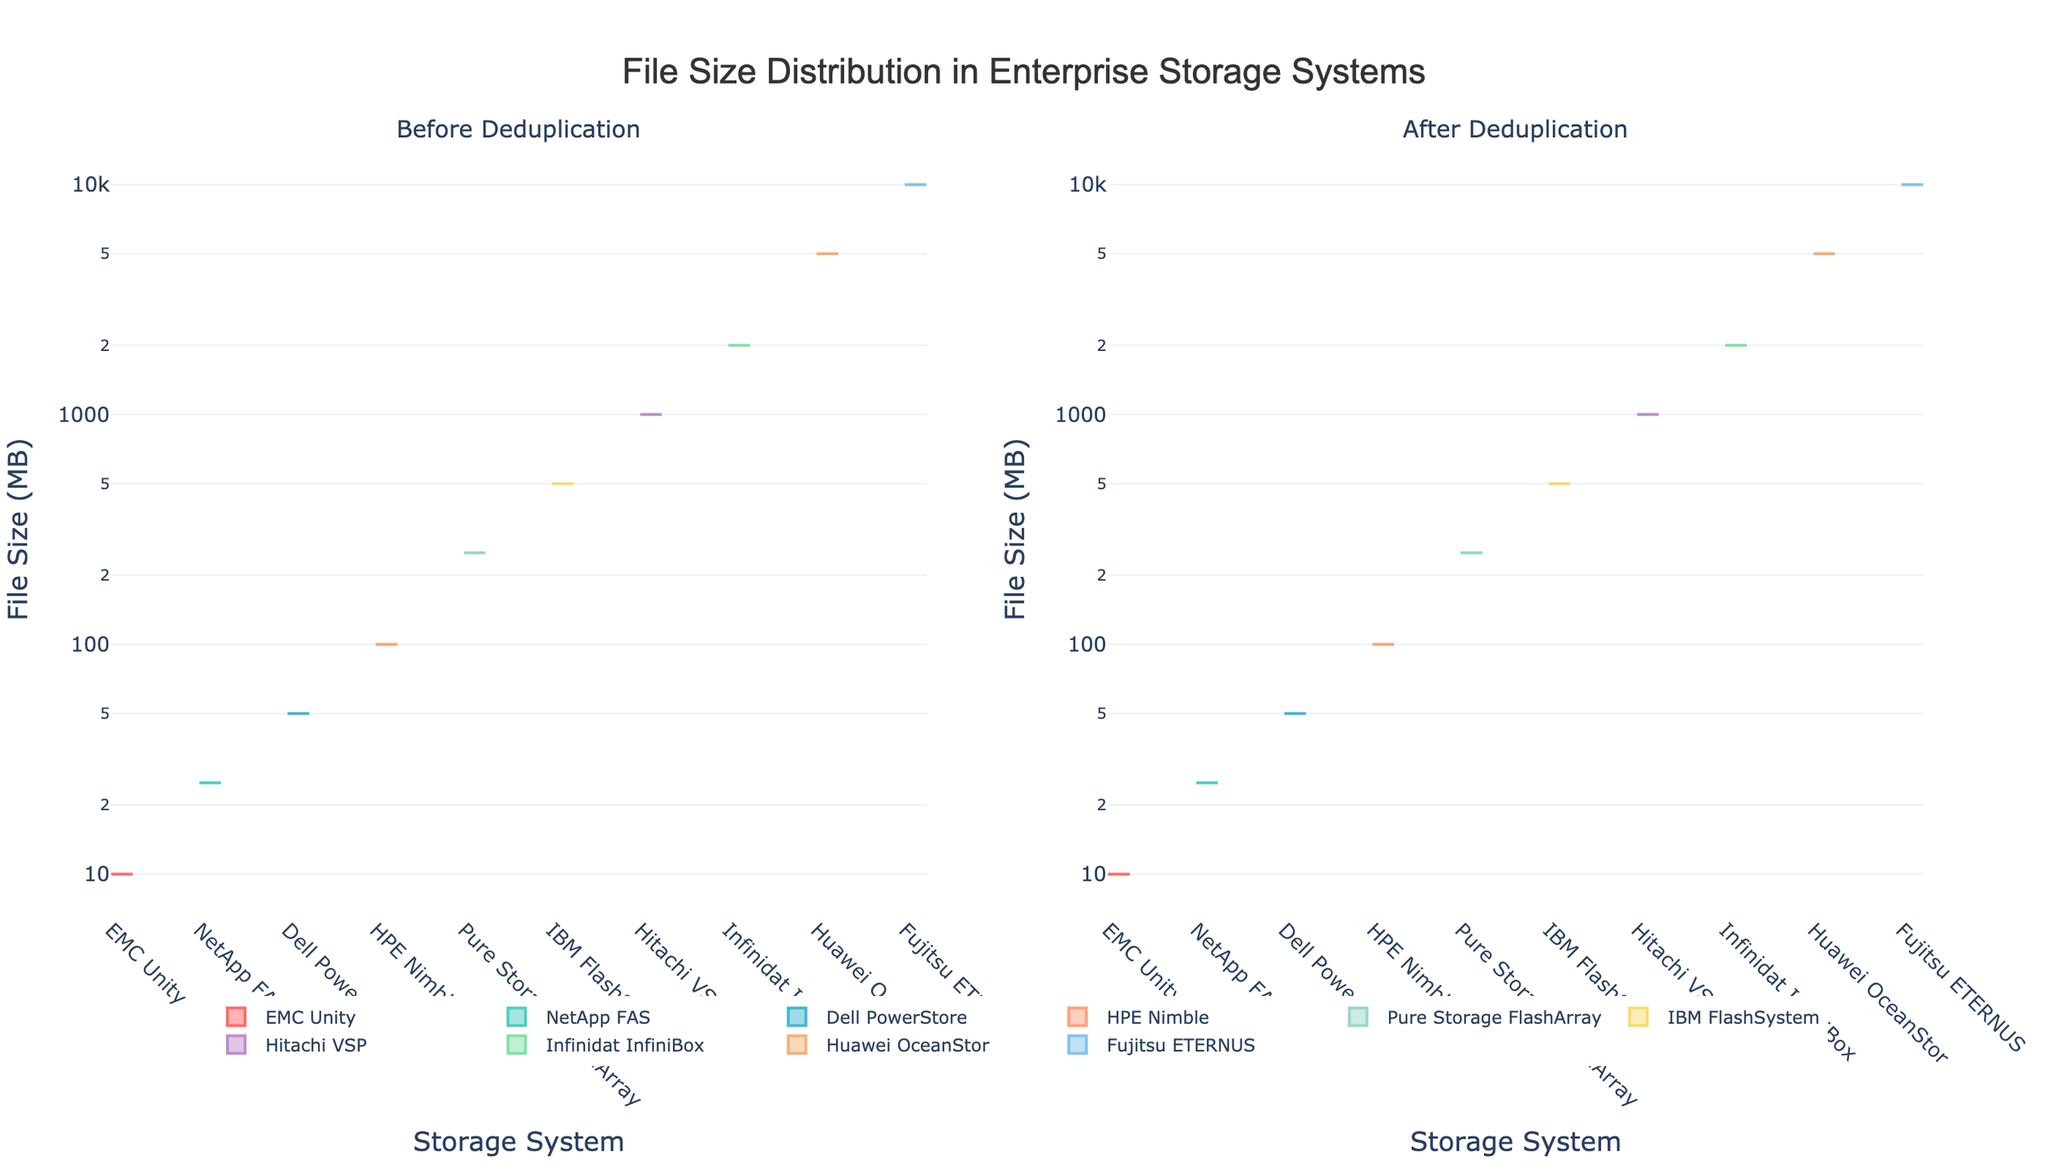What's the title of the figure? The title of a figure is typically found at the top and describes the main subject or finding of the plot. In this case, it says: 'File Size Distribution in Enterprise Storage Systems'.
Answer: File Size Distribution in Enterprise Storage Systems What are the two subplots comparing? The two subplots are comparing file size distributions before and after deduplication. The left subplot shows file size distributions before deduplication, while the right subplot shows them after deduplication.
Answer: Before Deduplication and After Deduplication Which storage system has the highest number of files before deduplication for the 10 MB size category? To find this, look at the left subplot and identify the storage system with the highest value for the 10 MB size category. Based on the height of the density lines, EMC Unity has the highest number of files.
Answer: EMC Unity Is the file size distribution generally reduced after deduplication? By comparing the heights and distributions of the density plots between the two subplots, it is evident that the number of files is generally lower after deduplication across different storage systems. The densities on the right subplot are lower compared to the left subplot for most storage systems.
Answer: Yes Which storage system shows the most significant reduction in file counts for the 500 MB size category after deduplication? Look at the density plots for the 500 MB size category in both subplots. Dell PowerStore experiences the most noticeable reduction in file counts (from a higher density in the left subplot to a lower density in the right subplot).
Answer: Dell PowerStore How does the file count for files of size 50 MB in Dell PowerStore compare before and after deduplication? Compare the densities for the 50 MB size category in the left and right subplots for Dell PowerStore. The file count decreases from 987 to 654 after deduplication, indicating a reduction.
Answer: Reduced What is the general trend observed in file sizes smaller than 100 MB after deduplication? Observing the density plots for file sizes smaller than 100 MB, there is a general reduction in the heights of the density plots, indicating fewer files of these sizes after deduplication.
Answer: Reduction Which storage system has the least reduction in file counts for 1000 MB files after deduplication? Compare the densities for 1000 MB files in both subplots. Hitachi VSP shows the least reduction, as its density plots are closest in height in the before and after subplots.
Answer: Hitachi VSP Do any storage systems show an increase in file counts after deduplication for any file size categories? Check both subplots for any file size categories where the density is higher after deduplication. No storage systems show an increase in file counts; all densities are equal or lower after deduplication.
Answer: No How many storage systems are represented in the figure? Count the number of distinct storage system names shown in each violin plot across both subplots. There are 10 different storage systems represented.
Answer: 10 